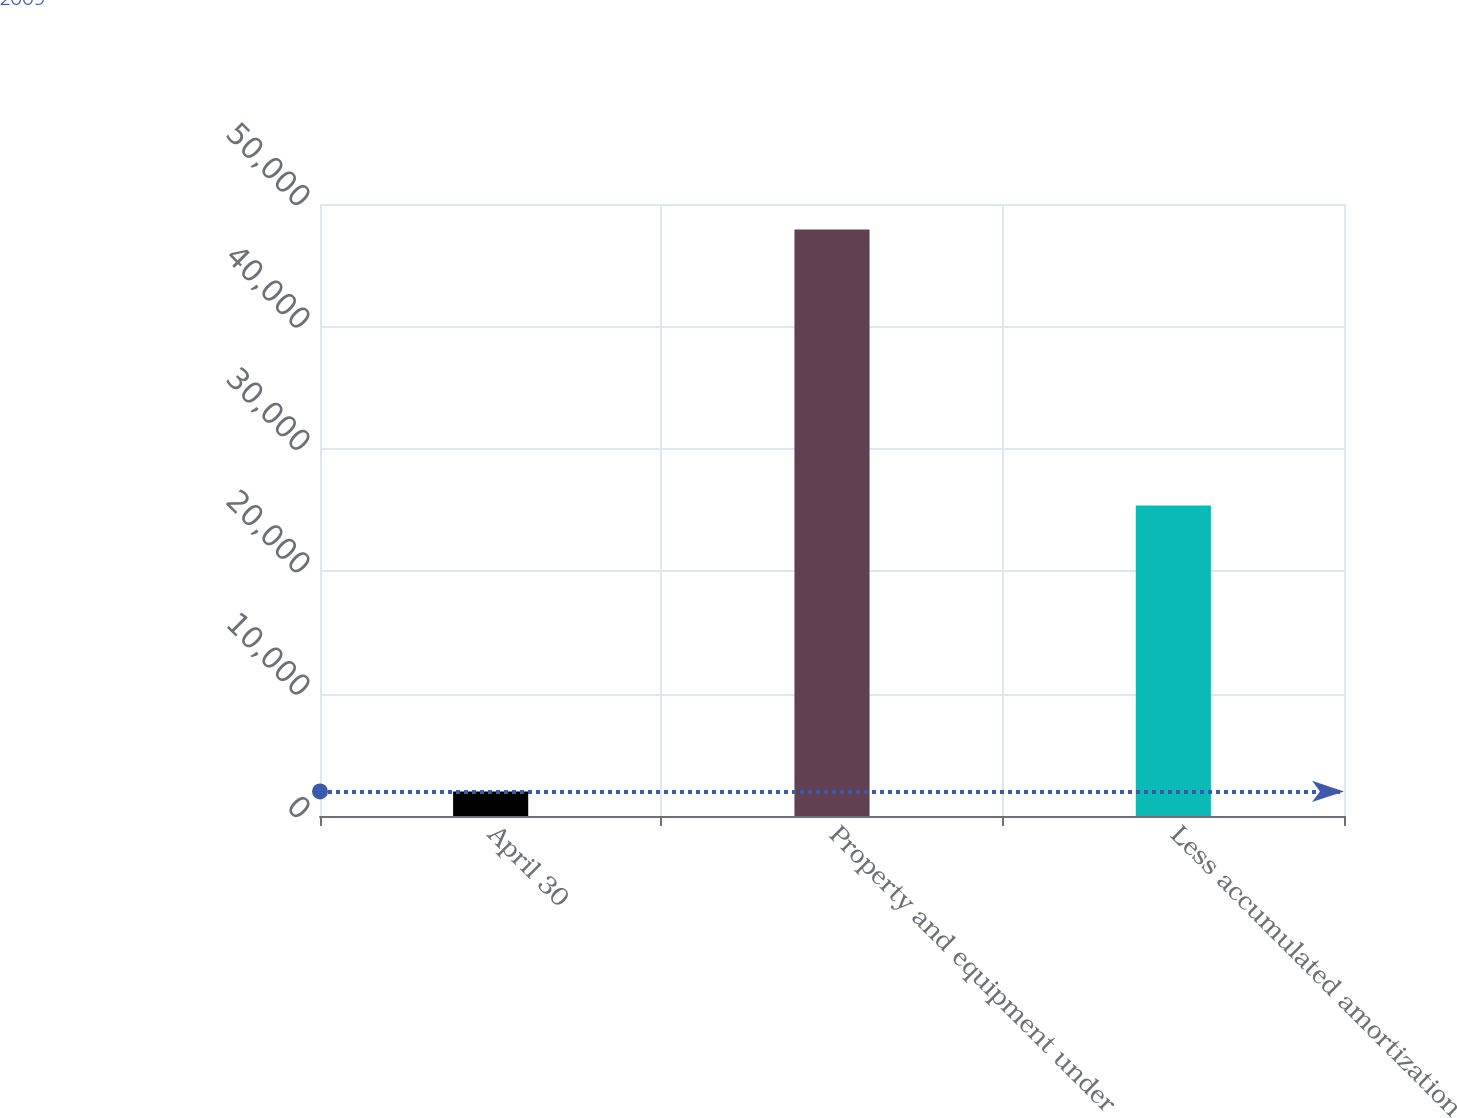<chart> <loc_0><loc_0><loc_500><loc_500><bar_chart><fcel>April 30<fcel>Property and equipment under<fcel>Less accumulated amortization<nl><fcel>2009<fcel>47913<fcel>25368<nl></chart> 